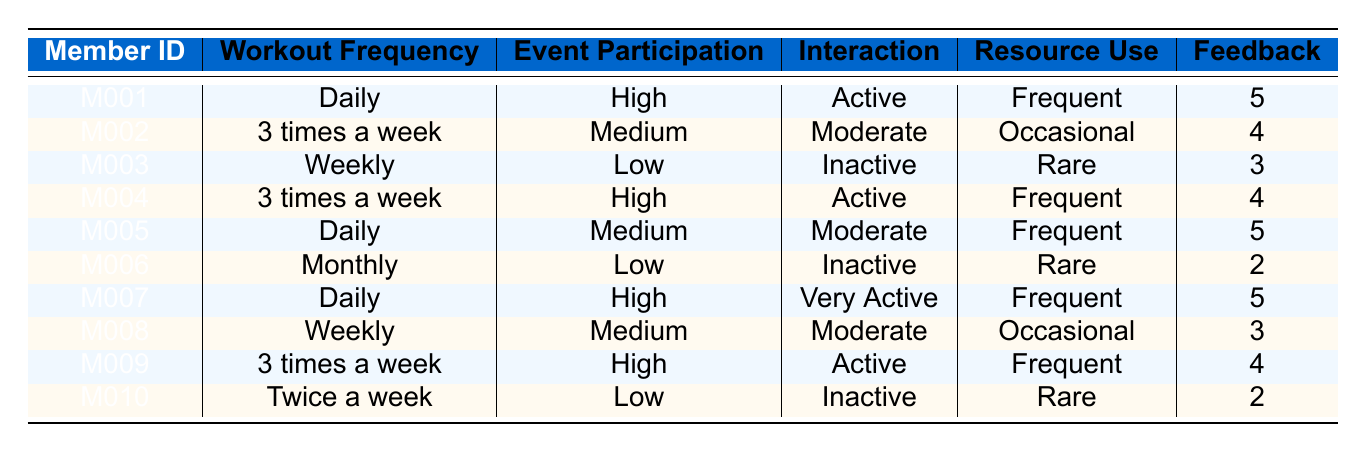What is the feedback rating of member M007? Member M007 is listed in the table. According to the fifth column titled "Feedback," the value is 5.
Answer: 5 How many members work out daily? From the table, we can count the entries under "Workout Frequency" that state "Daily." There are three instances (M001, M005, and M007).
Answer: 3 Which member has the highest feedback rating? By examining the "Feedback" column, the members with the highest rating of 5 are M001, M005, and M007. Therefore, there are multiple members with this rating, but they are all specified.
Answer: M001, M005, M007 What is the average feedback rating of members who interact very actively? To find this, we look at the member with "Interaction" marked as "Very Active," which is only M007, whose feedback rating is 5. Since there’s only one member, the average is simply the rating of that member.
Answer: 5 Is member M006 considered active in their interactions? The "Interaction" column for member M006 shows it as "Inactive." Therefore, the answer would be no.
Answer: No Which member has the most frequent usage of community resources? By checking the "Resource Use" column, members M001, M004, M005, and M007 are marked as "Frequent." However, the member with the most frequent involvement is M007.
Answer: M007 How many members interact at a "Moderate" level? By counting the instances in the "Interaction" column where it states "Moderate," we find this applies to members M002, M005, and M008.
Answer: 3 What are the workout frequencies of members with a feedback rating of 4? The members with a feedback rating of 4 are M002, M004, and M009. Their workout frequencies are "3 times a week," "3 times a week," and "3 times a week," respectively.
Answer: 3 times a week Is there any member who participates in events at a low level and has a high feedback rating? Analyzing the "Participation In Events" column, we see that M003 and M010 participate at "Low." Their ratings are 3 and 2, respectively, indicating neither has a high feedback rating.
Answer: No 